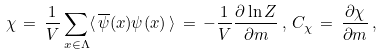<formula> <loc_0><loc_0><loc_500><loc_500>\chi \, = \, \frac { 1 } { V } \sum _ { x \in \Lambda } \langle \, \overline { \psi } ( x ) \psi ( x ) \, \rangle \, = \, - \frac { 1 } { V } \frac { \partial \ln Z } { \partial m } \, , \, C _ { \chi } \, = \, \frac { \partial \chi } { \partial m } \, ,</formula> 